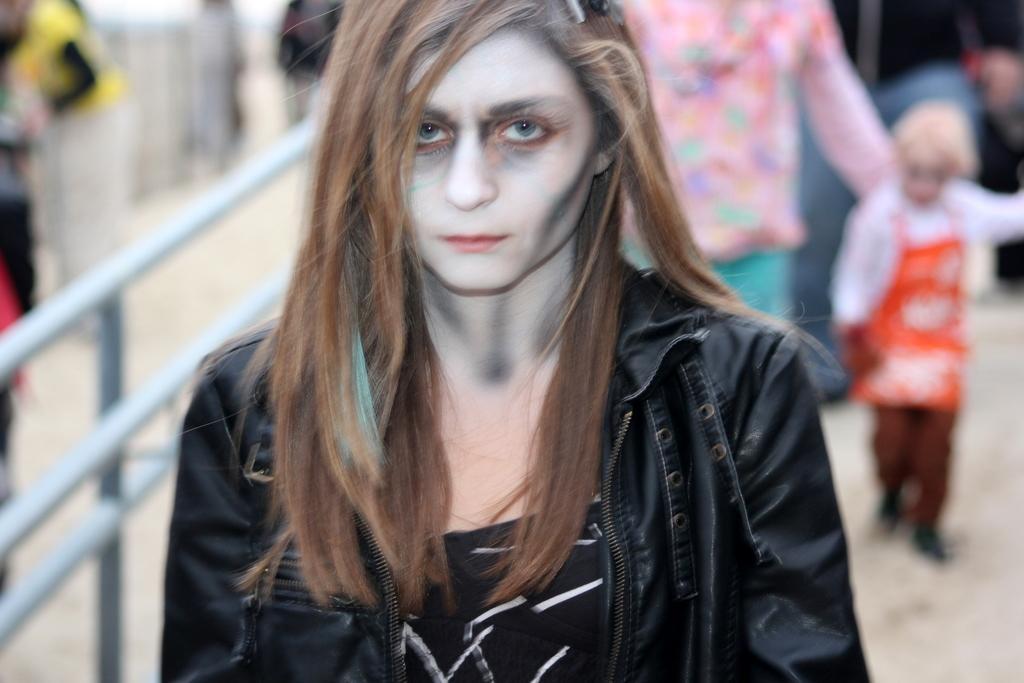How would you summarize this image in a sentence or two? In the picture we can see a woman standing in a black jacket and behind her we can see two people are walking and beside her we can see a part of the railing. 